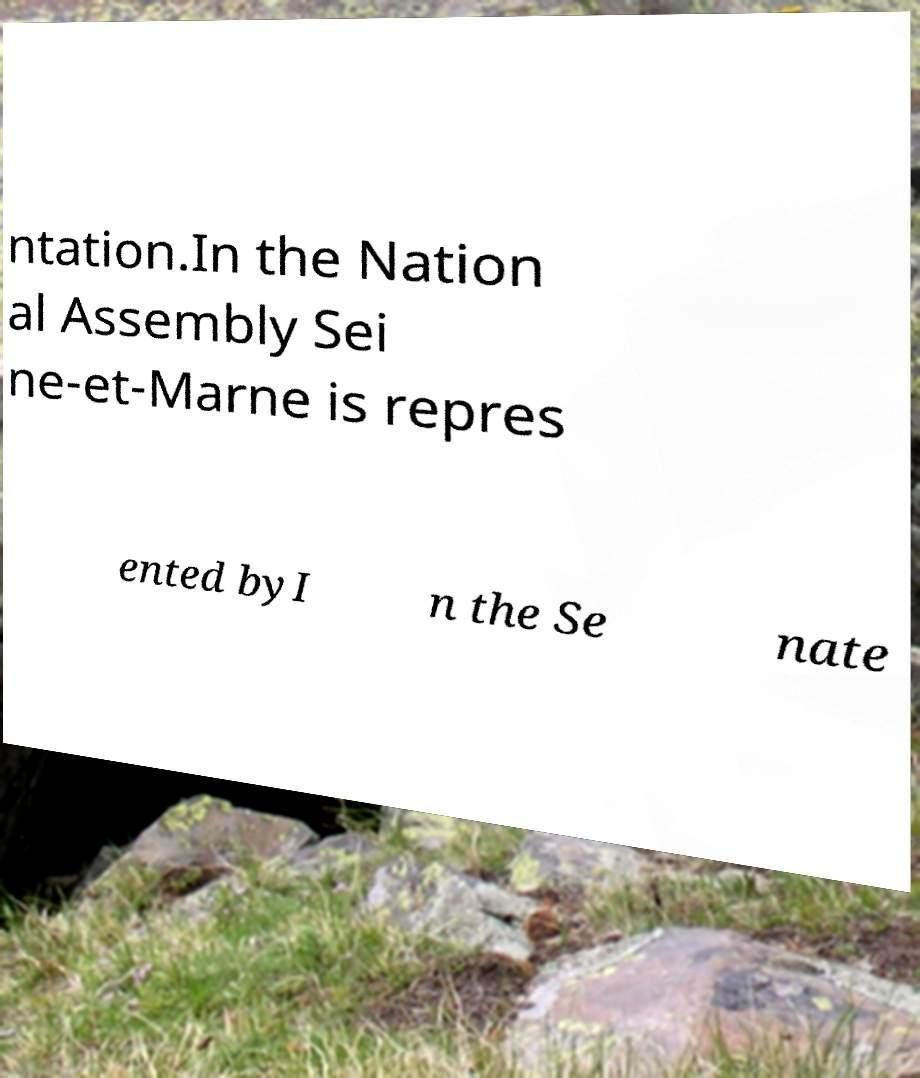What messages or text are displayed in this image? I need them in a readable, typed format. ntation.In the Nation al Assembly Sei ne-et-Marne is repres ented byI n the Se nate 